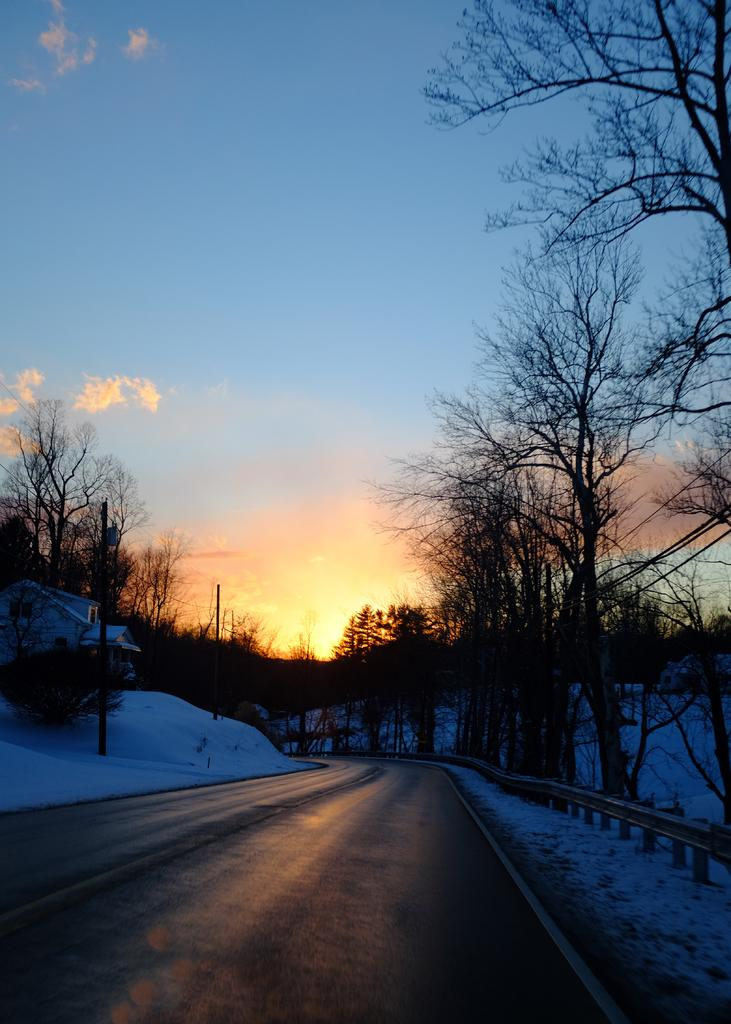What type of vegetation is present in the image? There are trees in the image. What type of pathway can be seen in the image? There is a road in the image. What is the weather condition in the image? There is snow in the image, indicating a cold or wintery condition. What structure is located on the left side of the image? There is a shed on the left side of the image. What is visible in the background of the image? The sky is visible in the background of the image. Where is the market located in the image? There is no market present in the image. What type of office can be seen in the image? There is no office present in the image. 